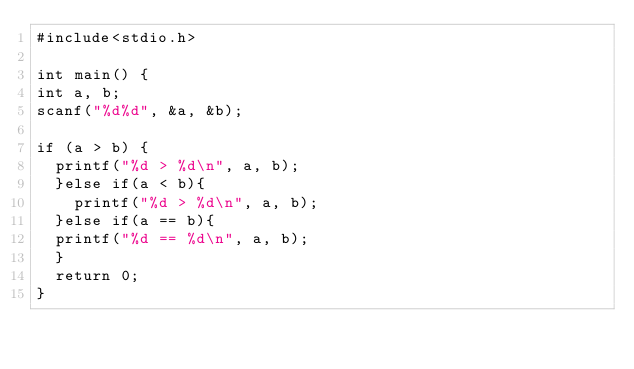Convert code to text. <code><loc_0><loc_0><loc_500><loc_500><_C_>#include<stdio.h>

int main() {
int a, b;
scanf("%d%d", &a, &b);

if (a > b) {
  printf("%d > %d\n", a, b);
  }else if(a < b){
    printf("%d > %d\n", a, b);
  }else if(a == b){
	printf("%d == %d\n", a, b);
  }
  return 0;
}</code> 